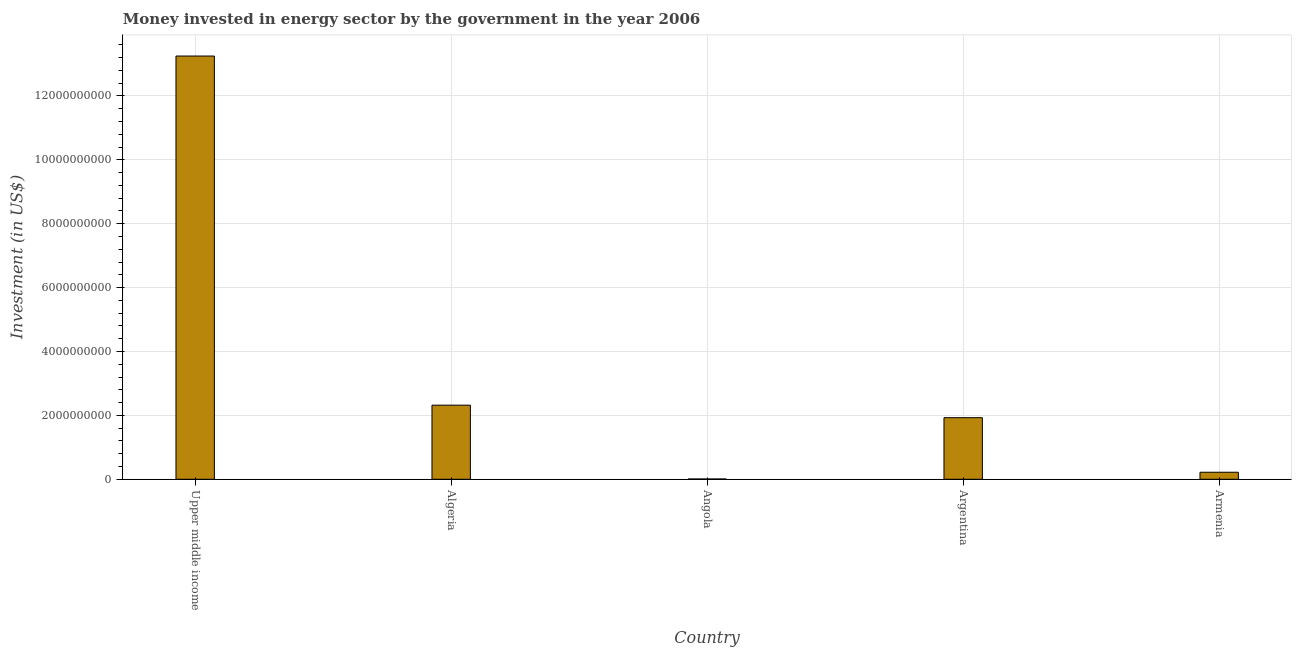Does the graph contain grids?
Give a very brief answer. Yes. What is the title of the graph?
Offer a very short reply. Money invested in energy sector by the government in the year 2006. What is the label or title of the X-axis?
Provide a succinct answer. Country. What is the label or title of the Y-axis?
Ensure brevity in your answer.  Investment (in US$). What is the investment in energy in Argentina?
Your response must be concise. 1.93e+09. Across all countries, what is the maximum investment in energy?
Provide a succinct answer. 1.32e+1. Across all countries, what is the minimum investment in energy?
Ensure brevity in your answer.  9.40e+06. In which country was the investment in energy maximum?
Offer a terse response. Upper middle income. In which country was the investment in energy minimum?
Provide a succinct answer. Angola. What is the sum of the investment in energy?
Ensure brevity in your answer.  1.77e+1. What is the difference between the investment in energy in Algeria and Armenia?
Offer a very short reply. 2.10e+09. What is the average investment in energy per country?
Your answer should be very brief. 3.55e+09. What is the median investment in energy?
Your answer should be very brief. 1.93e+09. In how many countries, is the investment in energy greater than 10000000000 US$?
Provide a succinct answer. 1. What is the ratio of the investment in energy in Algeria to that in Armenia?
Offer a terse response. 10.54. What is the difference between the highest and the second highest investment in energy?
Offer a very short reply. 1.09e+1. Is the sum of the investment in energy in Algeria and Armenia greater than the maximum investment in energy across all countries?
Your answer should be compact. No. What is the difference between the highest and the lowest investment in energy?
Your answer should be compact. 1.32e+1. How many countries are there in the graph?
Ensure brevity in your answer.  5. What is the difference between two consecutive major ticks on the Y-axis?
Offer a very short reply. 2.00e+09. What is the Investment (in US$) of Upper middle income?
Your response must be concise. 1.32e+1. What is the Investment (in US$) in Algeria?
Provide a succinct answer. 2.32e+09. What is the Investment (in US$) in Angola?
Provide a succinct answer. 9.40e+06. What is the Investment (in US$) in Argentina?
Offer a terse response. 1.93e+09. What is the Investment (in US$) of Armenia?
Keep it short and to the point. 2.20e+08. What is the difference between the Investment (in US$) in Upper middle income and Algeria?
Offer a very short reply. 1.09e+1. What is the difference between the Investment (in US$) in Upper middle income and Angola?
Your response must be concise. 1.32e+1. What is the difference between the Investment (in US$) in Upper middle income and Argentina?
Offer a very short reply. 1.13e+1. What is the difference between the Investment (in US$) in Upper middle income and Armenia?
Offer a very short reply. 1.30e+1. What is the difference between the Investment (in US$) in Algeria and Angola?
Your answer should be compact. 2.31e+09. What is the difference between the Investment (in US$) in Algeria and Argentina?
Keep it short and to the point. 3.92e+08. What is the difference between the Investment (in US$) in Algeria and Armenia?
Your answer should be very brief. 2.10e+09. What is the difference between the Investment (in US$) in Angola and Argentina?
Provide a short and direct response. -1.92e+09. What is the difference between the Investment (in US$) in Angola and Armenia?
Ensure brevity in your answer.  -2.11e+08. What is the difference between the Investment (in US$) in Argentina and Armenia?
Keep it short and to the point. 1.71e+09. What is the ratio of the Investment (in US$) in Upper middle income to that in Algeria?
Provide a short and direct response. 5.71. What is the ratio of the Investment (in US$) in Upper middle income to that in Angola?
Provide a short and direct response. 1409.51. What is the ratio of the Investment (in US$) in Upper middle income to that in Argentina?
Keep it short and to the point. 6.87. What is the ratio of the Investment (in US$) in Upper middle income to that in Armenia?
Give a very brief answer. 60.23. What is the ratio of the Investment (in US$) in Algeria to that in Angola?
Give a very brief answer. 246.81. What is the ratio of the Investment (in US$) in Algeria to that in Argentina?
Give a very brief answer. 1.2. What is the ratio of the Investment (in US$) in Algeria to that in Armenia?
Offer a very short reply. 10.54. What is the ratio of the Investment (in US$) in Angola to that in Argentina?
Make the answer very short. 0.01. What is the ratio of the Investment (in US$) in Angola to that in Armenia?
Ensure brevity in your answer.  0.04. What is the ratio of the Investment (in US$) in Argentina to that in Armenia?
Offer a terse response. 8.76. 